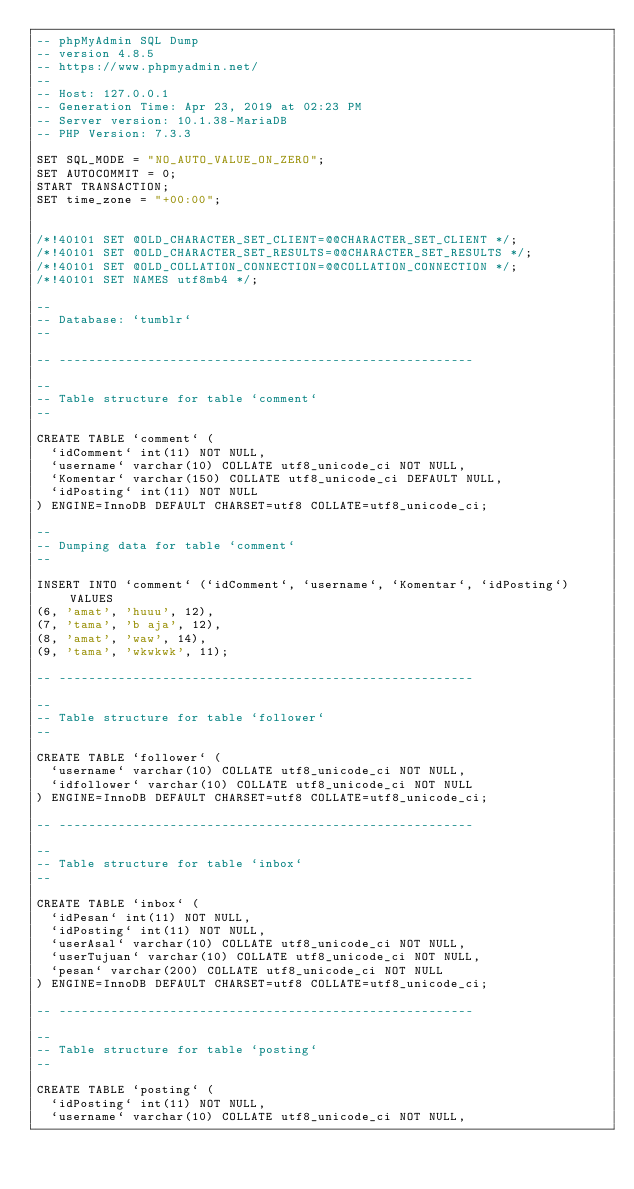<code> <loc_0><loc_0><loc_500><loc_500><_SQL_>-- phpMyAdmin SQL Dump
-- version 4.8.5
-- https://www.phpmyadmin.net/
--
-- Host: 127.0.0.1
-- Generation Time: Apr 23, 2019 at 02:23 PM
-- Server version: 10.1.38-MariaDB
-- PHP Version: 7.3.3

SET SQL_MODE = "NO_AUTO_VALUE_ON_ZERO";
SET AUTOCOMMIT = 0;
START TRANSACTION;
SET time_zone = "+00:00";


/*!40101 SET @OLD_CHARACTER_SET_CLIENT=@@CHARACTER_SET_CLIENT */;
/*!40101 SET @OLD_CHARACTER_SET_RESULTS=@@CHARACTER_SET_RESULTS */;
/*!40101 SET @OLD_COLLATION_CONNECTION=@@COLLATION_CONNECTION */;
/*!40101 SET NAMES utf8mb4 */;

--
-- Database: `tumblr`
--

-- --------------------------------------------------------

--
-- Table structure for table `comment`
--

CREATE TABLE `comment` (
  `idComment` int(11) NOT NULL,
  `username` varchar(10) COLLATE utf8_unicode_ci NOT NULL,
  `Komentar` varchar(150) COLLATE utf8_unicode_ci DEFAULT NULL,
  `idPosting` int(11) NOT NULL
) ENGINE=InnoDB DEFAULT CHARSET=utf8 COLLATE=utf8_unicode_ci;

--
-- Dumping data for table `comment`
--

INSERT INTO `comment` (`idComment`, `username`, `Komentar`, `idPosting`) VALUES
(6, 'amat', 'huuu', 12),
(7, 'tama', 'b aja', 12),
(8, 'amat', 'waw', 14),
(9, 'tama', 'wkwkwk', 11);

-- --------------------------------------------------------

--
-- Table structure for table `follower`
--

CREATE TABLE `follower` (
  `username` varchar(10) COLLATE utf8_unicode_ci NOT NULL,
  `idfollower` varchar(10) COLLATE utf8_unicode_ci NOT NULL
) ENGINE=InnoDB DEFAULT CHARSET=utf8 COLLATE=utf8_unicode_ci;

-- --------------------------------------------------------

--
-- Table structure for table `inbox`
--

CREATE TABLE `inbox` (
  `idPesan` int(11) NOT NULL,
  `idPosting` int(11) NOT NULL,
  `userAsal` varchar(10) COLLATE utf8_unicode_ci NOT NULL,
  `userTujuan` varchar(10) COLLATE utf8_unicode_ci NOT NULL,
  `pesan` varchar(200) COLLATE utf8_unicode_ci NOT NULL
) ENGINE=InnoDB DEFAULT CHARSET=utf8 COLLATE=utf8_unicode_ci;

-- --------------------------------------------------------

--
-- Table structure for table `posting`
--

CREATE TABLE `posting` (
  `idPosting` int(11) NOT NULL,
  `username` varchar(10) COLLATE utf8_unicode_ci NOT NULL,</code> 